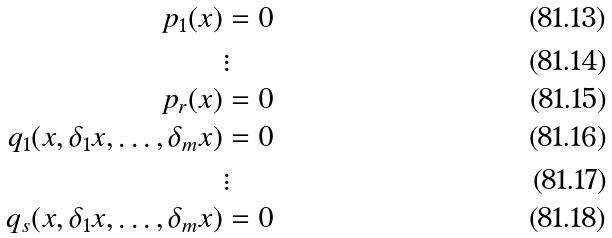<formula> <loc_0><loc_0><loc_500><loc_500>p _ { 1 } ( x ) & = 0 \\ & \vdots \\ p _ { r } ( x ) & = 0 \\ q _ { 1 } ( x , \delta _ { 1 } x , \dots , \delta _ { m } x ) & = 0 \\ & \vdots \\ q _ { s } ( x , \delta _ { 1 } x , \dots , \delta _ { m } x ) & = 0</formula> 